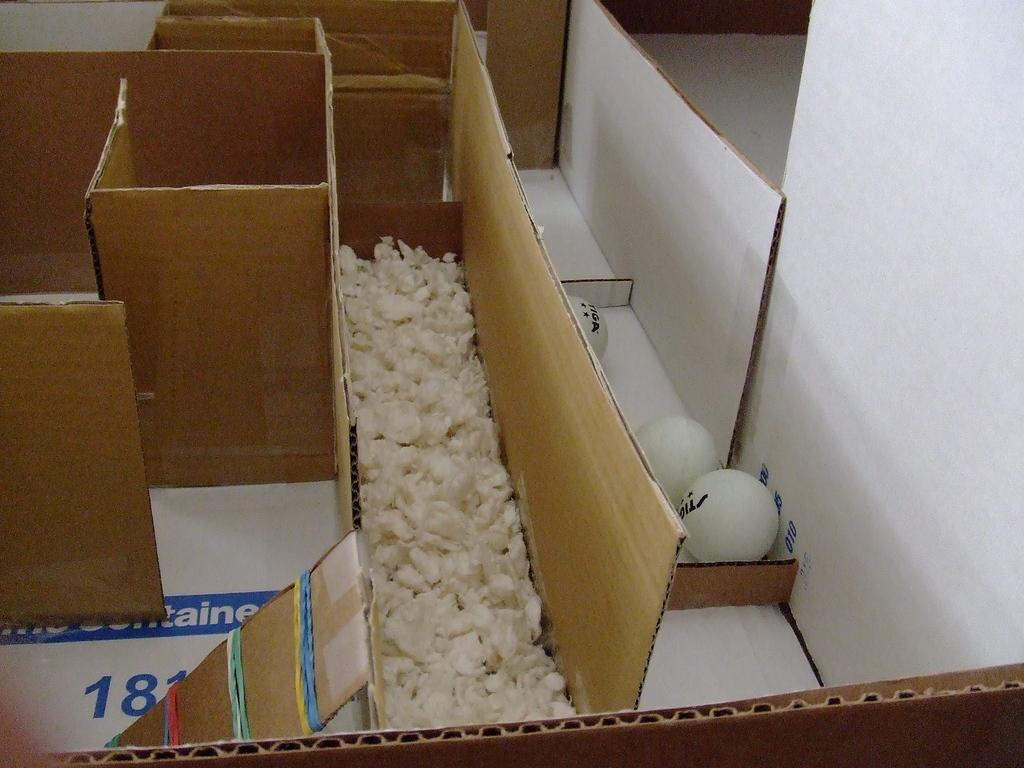<image>
Give a short and clear explanation of the subsequent image. Packages in a puzzle formats of Tiga brand balls 